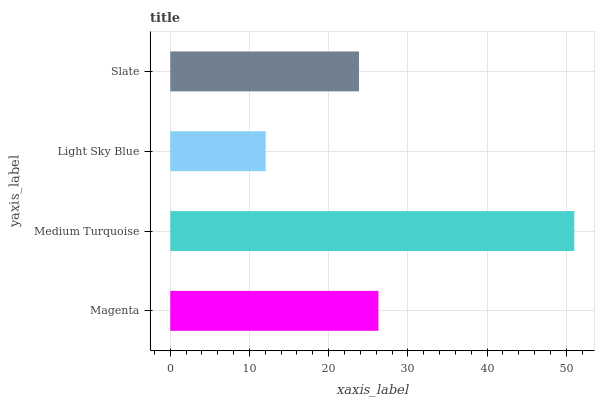Is Light Sky Blue the minimum?
Answer yes or no. Yes. Is Medium Turquoise the maximum?
Answer yes or no. Yes. Is Medium Turquoise the minimum?
Answer yes or no. No. Is Light Sky Blue the maximum?
Answer yes or no. No. Is Medium Turquoise greater than Light Sky Blue?
Answer yes or no. Yes. Is Light Sky Blue less than Medium Turquoise?
Answer yes or no. Yes. Is Light Sky Blue greater than Medium Turquoise?
Answer yes or no. No. Is Medium Turquoise less than Light Sky Blue?
Answer yes or no. No. Is Magenta the high median?
Answer yes or no. Yes. Is Slate the low median?
Answer yes or no. Yes. Is Slate the high median?
Answer yes or no. No. Is Magenta the low median?
Answer yes or no. No. 